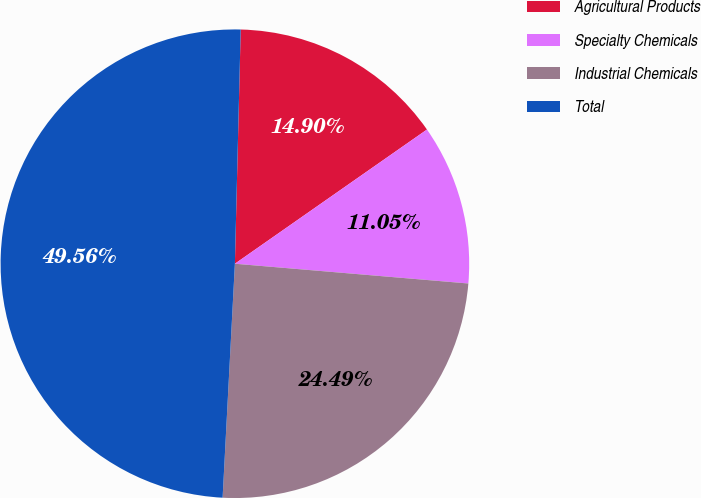Convert chart. <chart><loc_0><loc_0><loc_500><loc_500><pie_chart><fcel>Agricultural Products<fcel>Specialty Chemicals<fcel>Industrial Chemicals<fcel>Total<nl><fcel>14.9%<fcel>11.05%<fcel>24.49%<fcel>49.56%<nl></chart> 